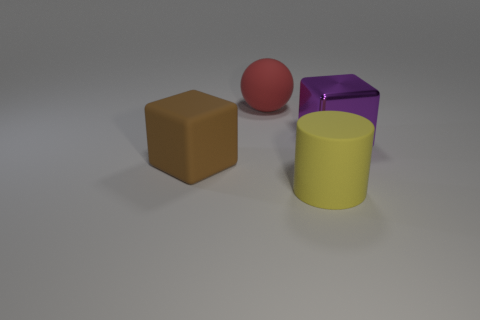Is there a purple rubber ball?
Make the answer very short. No. Are there any large yellow rubber cylinders behind the big yellow rubber cylinder?
Offer a terse response. No. What material is the other object that is the same shape as the large purple thing?
Your answer should be compact. Rubber. Are there any other things that are the same material as the red object?
Your answer should be compact. Yes. How many other things are the same shape as the big yellow object?
Your answer should be very brief. 0. There is a cube behind the block to the left of the large cylinder; how many rubber cylinders are left of it?
Your answer should be very brief. 1. How many large brown objects have the same shape as the large red rubber object?
Ensure brevity in your answer.  0. Is the color of the large block on the right side of the cylinder the same as the sphere?
Keep it short and to the point. No. What shape is the large red thing left of the rubber thing in front of the block on the left side of the big purple thing?
Provide a succinct answer. Sphere. There is a sphere; is its size the same as the block that is in front of the big metal block?
Provide a short and direct response. Yes. 